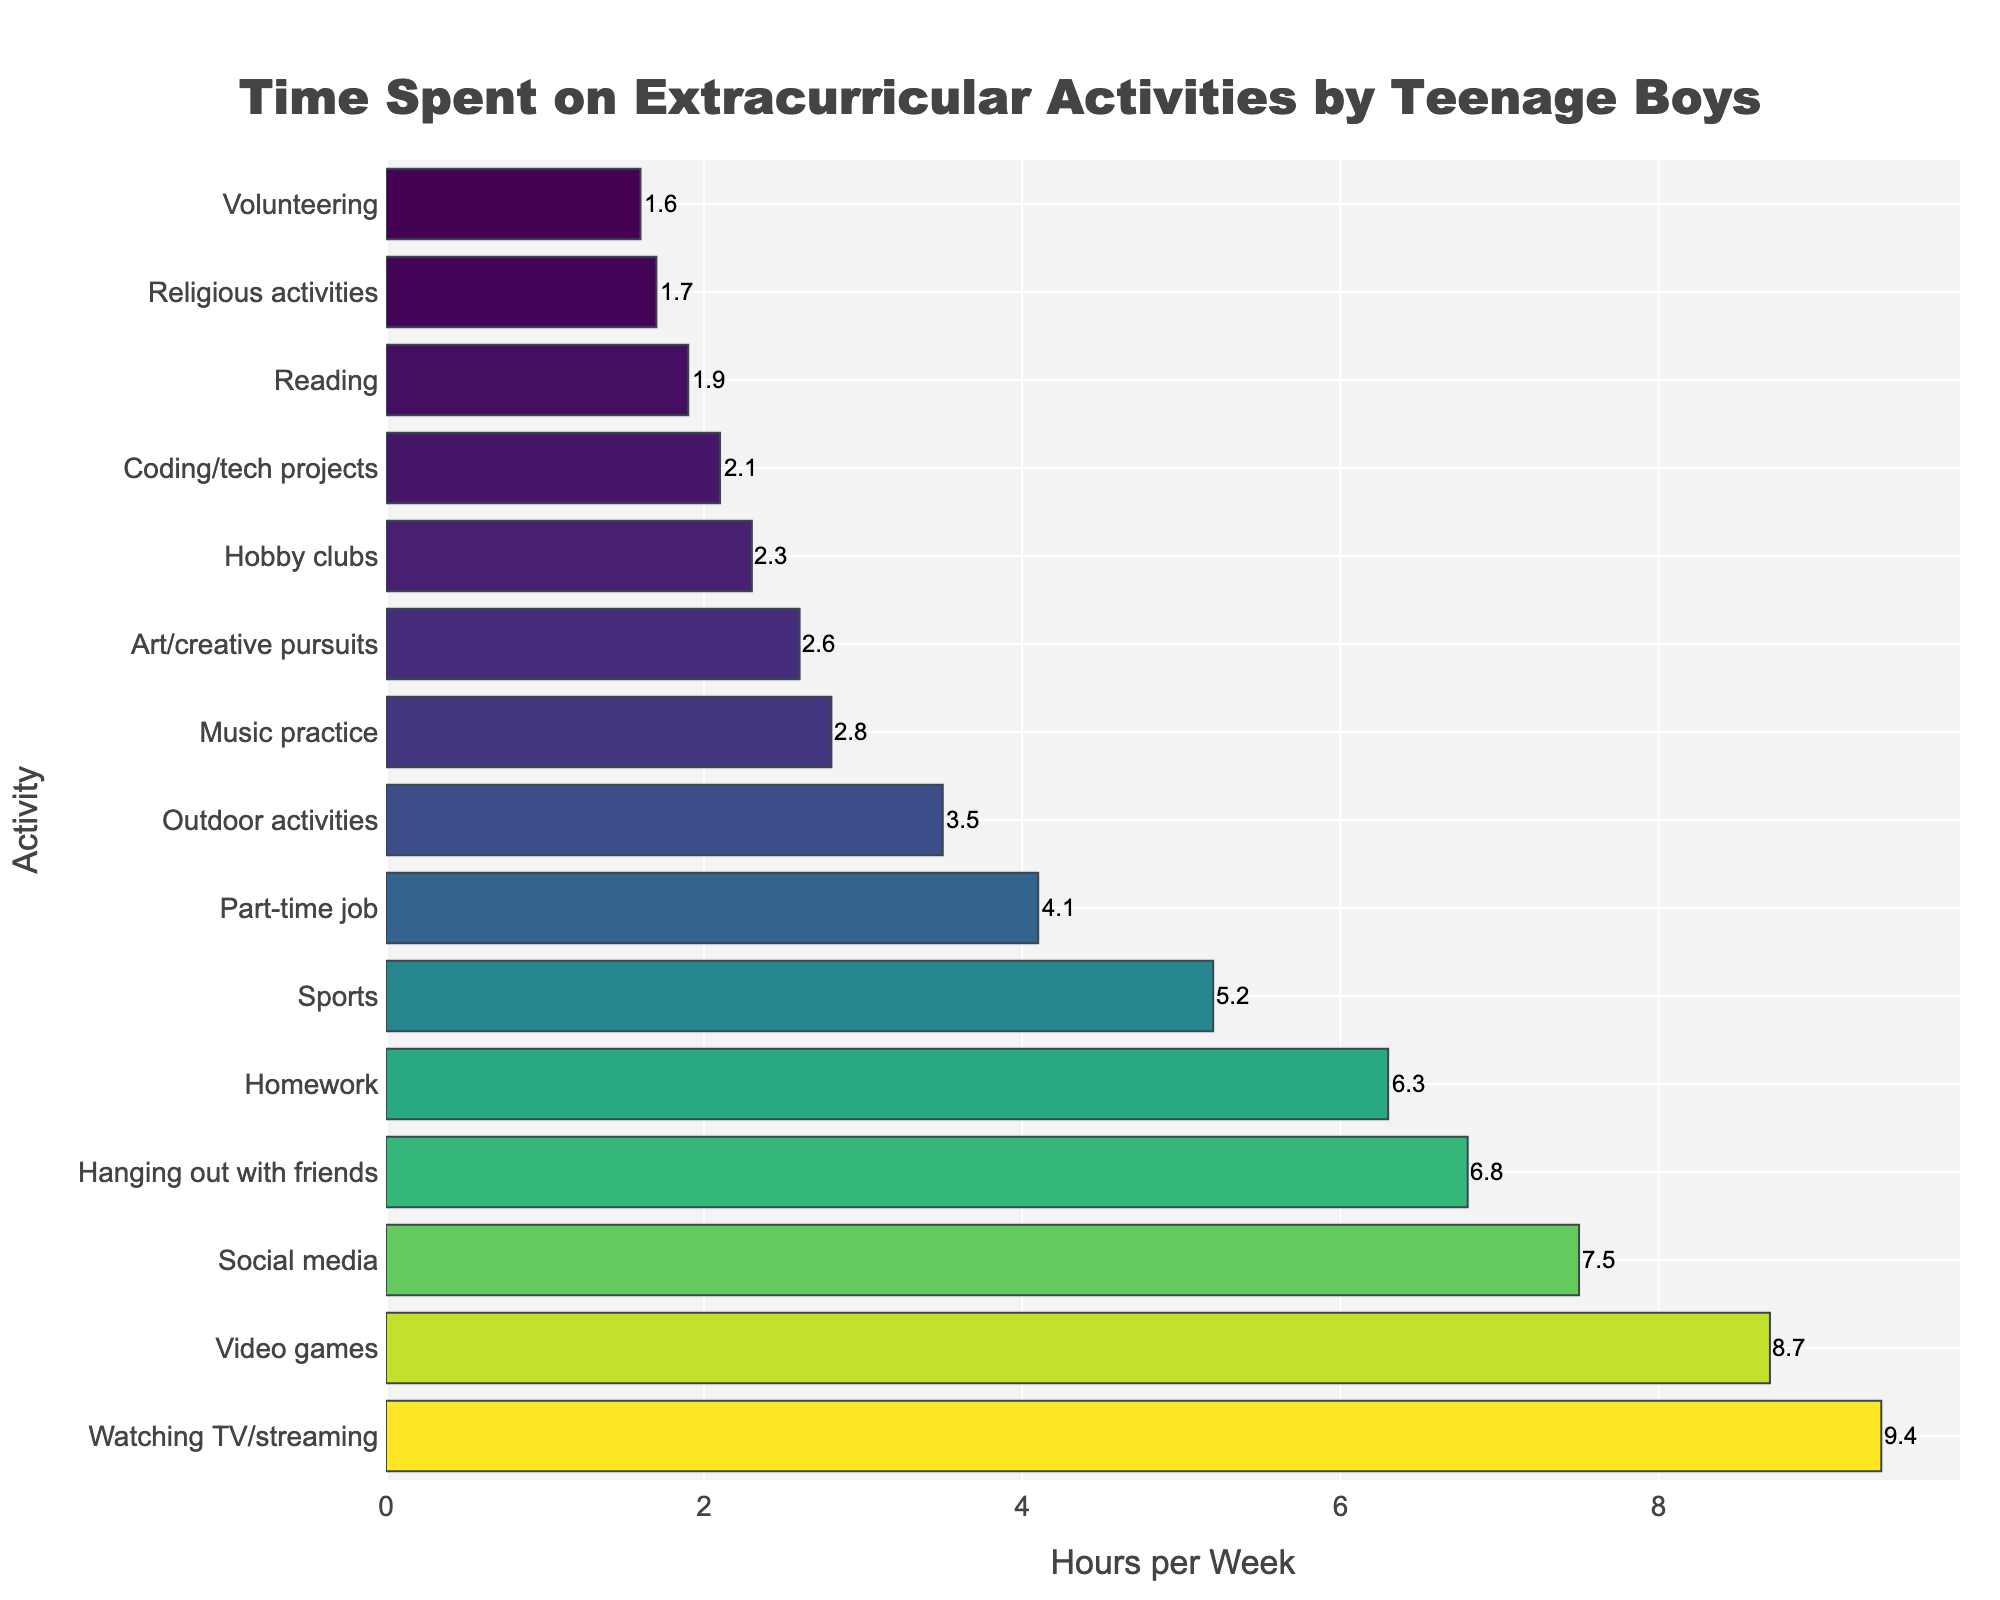What is the activity with the most time spent per week? The figure shows that watching TV/streaming has the longest bar, indicating the most hours per week.
Answer: Watching TV/streaming How many more hours are spent on video games compared to music practice? The bar for video games represents 8.7 hours, and the bar for music practice represents 2.8 hours. Subtracting these gives 8.7 - 2.8.
Answer: 5.9 hours Which activity takes more time: hanging out with friends or social media? Comparing the lengths of the bars, hanging out with friends is 6.8 hours, and social media is 7.5 hours.
Answer: Social media Which activities have more than 5 hours spent per week? The bars longer than 5 hours represent watching TV/streaming, video games, social media, homework, and hanging out with friends.
Answer: Watching TV/streaming, Video games, Social media, Homework, Hanging out with friends Which activity has the least time spent per week, and how many hours is it? The shortest bar in the chart represents volunteering, showing 1.6 hours per week.
Answer: Volunteering, 1.6 hours What is the total time spent on sports, video games, and music practice together? Adding the hours for sports (5.2), video games (8.7), and music practice (2.8), we get 5.2 + 8.7 + 2.8.
Answer: 16.7 hours Is more time spent on homework or hanging out with friends? The bars show 6.3 hours for homework and 6.8 hours for hanging out with friends, with the latter being longer.
Answer: Hanging out with friends What is the difference in hours spent between coding/tech projects and art/creative pursuits? The figure shows 2.1 hours for coding/tech projects and 2.6 hours for art/creative pursuits. Subtracting these gives 2.6 - 2.1.
Answer: 0.5 hours How many hours per week are spent on outdoor activities? The bar for outdoor activities indicates 3.5 hours per week.
Answer: 3.5 hours Which activity, reading or part-time job, has fewer hours dedicated to it? The bars show 1.9 hours for reading and 4.1 hours for a part-time job, with reading being shorter.
Answer: Reading 